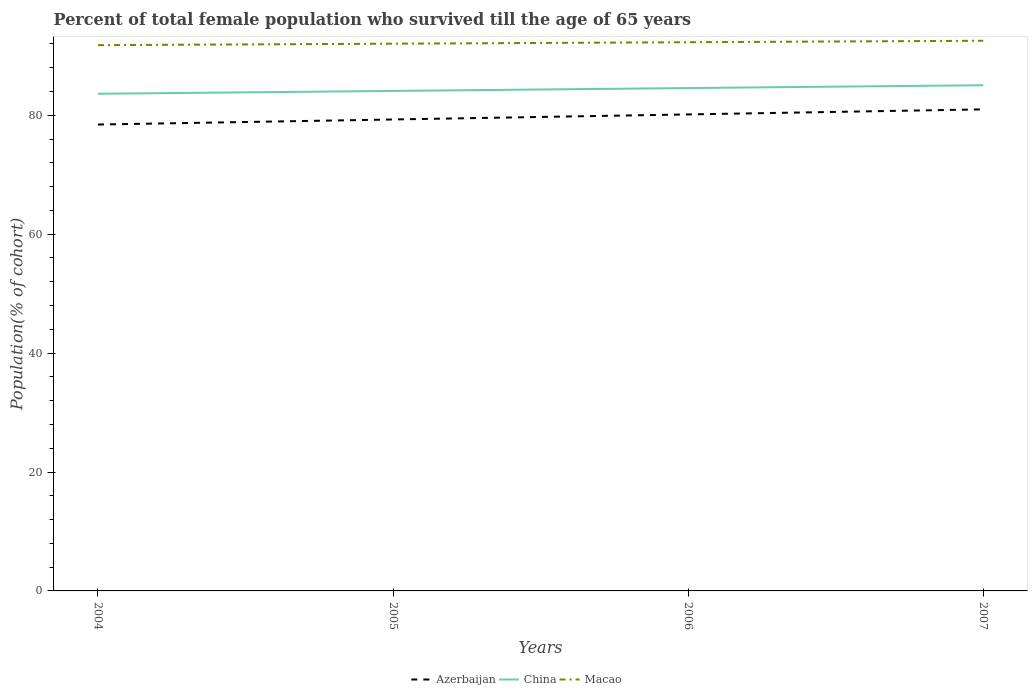Does the line corresponding to China intersect with the line corresponding to Macao?
Provide a short and direct response. No. Is the number of lines equal to the number of legend labels?
Offer a very short reply. Yes. Across all years, what is the maximum percentage of total female population who survived till the age of 65 years in Azerbaijan?
Provide a succinct answer. 78.44. What is the total percentage of total female population who survived till the age of 65 years in China in the graph?
Your answer should be very brief. -0.48. What is the difference between the highest and the second highest percentage of total female population who survived till the age of 65 years in Azerbaijan?
Keep it short and to the point. 2.55. How many lines are there?
Your response must be concise. 3. What is the difference between two consecutive major ticks on the Y-axis?
Your answer should be very brief. 20. Does the graph contain any zero values?
Keep it short and to the point. No. Where does the legend appear in the graph?
Give a very brief answer. Bottom center. How are the legend labels stacked?
Give a very brief answer. Horizontal. What is the title of the graph?
Provide a short and direct response. Percent of total female population who survived till the age of 65 years. Does "Tuvalu" appear as one of the legend labels in the graph?
Give a very brief answer. No. What is the label or title of the Y-axis?
Your answer should be compact. Population(% of cohort). What is the Population(% of cohort) of Azerbaijan in 2004?
Your answer should be compact. 78.44. What is the Population(% of cohort) in China in 2004?
Your response must be concise. 83.62. What is the Population(% of cohort) of Macao in 2004?
Provide a short and direct response. 91.8. What is the Population(% of cohort) in Azerbaijan in 2005?
Give a very brief answer. 79.3. What is the Population(% of cohort) of China in 2005?
Ensure brevity in your answer.  84.1. What is the Population(% of cohort) in Macao in 2005?
Your answer should be compact. 92.04. What is the Population(% of cohort) in Azerbaijan in 2006?
Make the answer very short. 80.15. What is the Population(% of cohort) of China in 2006?
Make the answer very short. 84.58. What is the Population(% of cohort) of Macao in 2006?
Your answer should be compact. 92.29. What is the Population(% of cohort) of Azerbaijan in 2007?
Your response must be concise. 81. What is the Population(% of cohort) in China in 2007?
Keep it short and to the point. 85.06. What is the Population(% of cohort) of Macao in 2007?
Provide a succinct answer. 92.53. Across all years, what is the maximum Population(% of cohort) in Azerbaijan?
Keep it short and to the point. 81. Across all years, what is the maximum Population(% of cohort) in China?
Offer a terse response. 85.06. Across all years, what is the maximum Population(% of cohort) in Macao?
Provide a short and direct response. 92.53. Across all years, what is the minimum Population(% of cohort) in Azerbaijan?
Give a very brief answer. 78.44. Across all years, what is the minimum Population(% of cohort) of China?
Provide a succinct answer. 83.62. Across all years, what is the minimum Population(% of cohort) in Macao?
Offer a very short reply. 91.8. What is the total Population(% of cohort) of Azerbaijan in the graph?
Offer a terse response. 318.88. What is the total Population(% of cohort) in China in the graph?
Your response must be concise. 337.35. What is the total Population(% of cohort) in Macao in the graph?
Provide a succinct answer. 368.66. What is the difference between the Population(% of cohort) in Azerbaijan in 2004 and that in 2005?
Provide a succinct answer. -0.85. What is the difference between the Population(% of cohort) in China in 2004 and that in 2005?
Your response must be concise. -0.48. What is the difference between the Population(% of cohort) in Macao in 2004 and that in 2005?
Your answer should be compact. -0.25. What is the difference between the Population(% of cohort) in Azerbaijan in 2004 and that in 2006?
Provide a succinct answer. -1.7. What is the difference between the Population(% of cohort) in China in 2004 and that in 2006?
Provide a short and direct response. -0.96. What is the difference between the Population(% of cohort) of Macao in 2004 and that in 2006?
Make the answer very short. -0.49. What is the difference between the Population(% of cohort) of Azerbaijan in 2004 and that in 2007?
Keep it short and to the point. -2.55. What is the difference between the Population(% of cohort) of China in 2004 and that in 2007?
Your answer should be very brief. -1.44. What is the difference between the Population(% of cohort) of Macao in 2004 and that in 2007?
Give a very brief answer. -0.74. What is the difference between the Population(% of cohort) of Azerbaijan in 2005 and that in 2006?
Offer a very short reply. -0.85. What is the difference between the Population(% of cohort) in China in 2005 and that in 2006?
Provide a short and direct response. -0.48. What is the difference between the Population(% of cohort) of Macao in 2005 and that in 2006?
Keep it short and to the point. -0.25. What is the difference between the Population(% of cohort) in Azerbaijan in 2005 and that in 2007?
Offer a terse response. -1.7. What is the difference between the Population(% of cohort) of China in 2005 and that in 2007?
Ensure brevity in your answer.  -0.96. What is the difference between the Population(% of cohort) in Macao in 2005 and that in 2007?
Your answer should be compact. -0.49. What is the difference between the Population(% of cohort) in Azerbaijan in 2006 and that in 2007?
Offer a terse response. -0.85. What is the difference between the Population(% of cohort) in China in 2006 and that in 2007?
Offer a terse response. -0.48. What is the difference between the Population(% of cohort) in Macao in 2006 and that in 2007?
Provide a short and direct response. -0.25. What is the difference between the Population(% of cohort) in Azerbaijan in 2004 and the Population(% of cohort) in China in 2005?
Your answer should be very brief. -5.65. What is the difference between the Population(% of cohort) of Azerbaijan in 2004 and the Population(% of cohort) of Macao in 2005?
Provide a short and direct response. -13.6. What is the difference between the Population(% of cohort) of China in 2004 and the Population(% of cohort) of Macao in 2005?
Provide a short and direct response. -8.42. What is the difference between the Population(% of cohort) in Azerbaijan in 2004 and the Population(% of cohort) in China in 2006?
Make the answer very short. -6.13. What is the difference between the Population(% of cohort) in Azerbaijan in 2004 and the Population(% of cohort) in Macao in 2006?
Provide a succinct answer. -13.84. What is the difference between the Population(% of cohort) of China in 2004 and the Population(% of cohort) of Macao in 2006?
Offer a terse response. -8.67. What is the difference between the Population(% of cohort) of Azerbaijan in 2004 and the Population(% of cohort) of China in 2007?
Offer a very short reply. -6.61. What is the difference between the Population(% of cohort) in Azerbaijan in 2004 and the Population(% of cohort) in Macao in 2007?
Offer a terse response. -14.09. What is the difference between the Population(% of cohort) of China in 2004 and the Population(% of cohort) of Macao in 2007?
Your answer should be very brief. -8.92. What is the difference between the Population(% of cohort) of Azerbaijan in 2005 and the Population(% of cohort) of China in 2006?
Make the answer very short. -5.28. What is the difference between the Population(% of cohort) in Azerbaijan in 2005 and the Population(% of cohort) in Macao in 2006?
Keep it short and to the point. -12.99. What is the difference between the Population(% of cohort) of China in 2005 and the Population(% of cohort) of Macao in 2006?
Give a very brief answer. -8.19. What is the difference between the Population(% of cohort) in Azerbaijan in 2005 and the Population(% of cohort) in China in 2007?
Offer a very short reply. -5.76. What is the difference between the Population(% of cohort) in Azerbaijan in 2005 and the Population(% of cohort) in Macao in 2007?
Keep it short and to the point. -13.24. What is the difference between the Population(% of cohort) of China in 2005 and the Population(% of cohort) of Macao in 2007?
Offer a very short reply. -8.44. What is the difference between the Population(% of cohort) of Azerbaijan in 2006 and the Population(% of cohort) of China in 2007?
Offer a terse response. -4.91. What is the difference between the Population(% of cohort) in Azerbaijan in 2006 and the Population(% of cohort) in Macao in 2007?
Your response must be concise. -12.39. What is the difference between the Population(% of cohort) of China in 2006 and the Population(% of cohort) of Macao in 2007?
Keep it short and to the point. -7.96. What is the average Population(% of cohort) in Azerbaijan per year?
Offer a very short reply. 79.72. What is the average Population(% of cohort) in China per year?
Offer a very short reply. 84.34. What is the average Population(% of cohort) in Macao per year?
Offer a very short reply. 92.17. In the year 2004, what is the difference between the Population(% of cohort) of Azerbaijan and Population(% of cohort) of China?
Your answer should be compact. -5.17. In the year 2004, what is the difference between the Population(% of cohort) in Azerbaijan and Population(% of cohort) in Macao?
Give a very brief answer. -13.35. In the year 2004, what is the difference between the Population(% of cohort) of China and Population(% of cohort) of Macao?
Provide a succinct answer. -8.18. In the year 2005, what is the difference between the Population(% of cohort) of Azerbaijan and Population(% of cohort) of China?
Ensure brevity in your answer.  -4.8. In the year 2005, what is the difference between the Population(% of cohort) of Azerbaijan and Population(% of cohort) of Macao?
Offer a very short reply. -12.75. In the year 2005, what is the difference between the Population(% of cohort) in China and Population(% of cohort) in Macao?
Give a very brief answer. -7.94. In the year 2006, what is the difference between the Population(% of cohort) of Azerbaijan and Population(% of cohort) of China?
Keep it short and to the point. -4.43. In the year 2006, what is the difference between the Population(% of cohort) of Azerbaijan and Population(% of cohort) of Macao?
Your answer should be very brief. -12.14. In the year 2006, what is the difference between the Population(% of cohort) of China and Population(% of cohort) of Macao?
Make the answer very short. -7.71. In the year 2007, what is the difference between the Population(% of cohort) in Azerbaijan and Population(% of cohort) in China?
Ensure brevity in your answer.  -4.06. In the year 2007, what is the difference between the Population(% of cohort) of Azerbaijan and Population(% of cohort) of Macao?
Your response must be concise. -11.54. In the year 2007, what is the difference between the Population(% of cohort) of China and Population(% of cohort) of Macao?
Keep it short and to the point. -7.48. What is the ratio of the Population(% of cohort) of Azerbaijan in 2004 to that in 2005?
Your answer should be very brief. 0.99. What is the ratio of the Population(% of cohort) of Macao in 2004 to that in 2005?
Make the answer very short. 1. What is the ratio of the Population(% of cohort) in Azerbaijan in 2004 to that in 2006?
Offer a terse response. 0.98. What is the ratio of the Population(% of cohort) in China in 2004 to that in 2006?
Provide a succinct answer. 0.99. What is the ratio of the Population(% of cohort) in Azerbaijan in 2004 to that in 2007?
Keep it short and to the point. 0.97. What is the ratio of the Population(% of cohort) of China in 2004 to that in 2007?
Keep it short and to the point. 0.98. What is the ratio of the Population(% of cohort) of China in 2005 to that in 2006?
Give a very brief answer. 0.99. What is the ratio of the Population(% of cohort) of China in 2005 to that in 2007?
Your response must be concise. 0.99. What is the ratio of the Population(% of cohort) of Macao in 2005 to that in 2007?
Keep it short and to the point. 0.99. What is the ratio of the Population(% of cohort) of Macao in 2006 to that in 2007?
Provide a short and direct response. 1. What is the difference between the highest and the second highest Population(% of cohort) of Azerbaijan?
Your answer should be very brief. 0.85. What is the difference between the highest and the second highest Population(% of cohort) of China?
Provide a short and direct response. 0.48. What is the difference between the highest and the second highest Population(% of cohort) of Macao?
Your answer should be very brief. 0.25. What is the difference between the highest and the lowest Population(% of cohort) in Azerbaijan?
Ensure brevity in your answer.  2.55. What is the difference between the highest and the lowest Population(% of cohort) of China?
Your response must be concise. 1.44. What is the difference between the highest and the lowest Population(% of cohort) of Macao?
Give a very brief answer. 0.74. 